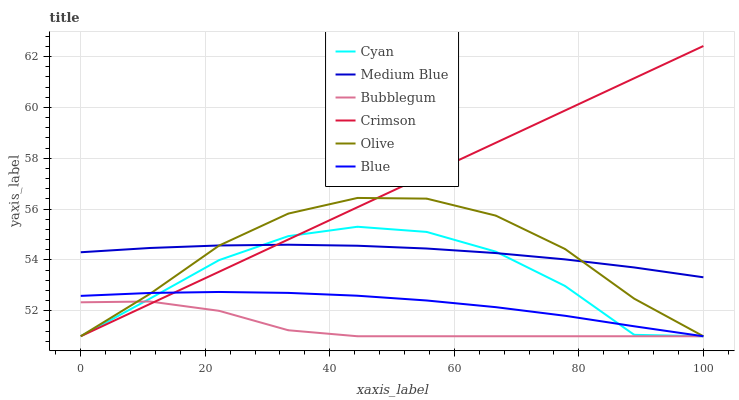Does Bubblegum have the minimum area under the curve?
Answer yes or no. Yes. Does Crimson have the maximum area under the curve?
Answer yes or no. Yes. Does Medium Blue have the minimum area under the curve?
Answer yes or no. No. Does Medium Blue have the maximum area under the curve?
Answer yes or no. No. Is Crimson the smoothest?
Answer yes or no. Yes. Is Cyan the roughest?
Answer yes or no. Yes. Is Medium Blue the smoothest?
Answer yes or no. No. Is Medium Blue the roughest?
Answer yes or no. No. Does Medium Blue have the lowest value?
Answer yes or no. No. Does Crimson have the highest value?
Answer yes or no. Yes. Does Medium Blue have the highest value?
Answer yes or no. No. Is Blue less than Medium Blue?
Answer yes or no. Yes. Is Medium Blue greater than Bubblegum?
Answer yes or no. Yes. Does Bubblegum intersect Crimson?
Answer yes or no. Yes. Is Bubblegum less than Crimson?
Answer yes or no. No. Is Bubblegum greater than Crimson?
Answer yes or no. No. Does Blue intersect Medium Blue?
Answer yes or no. No. 